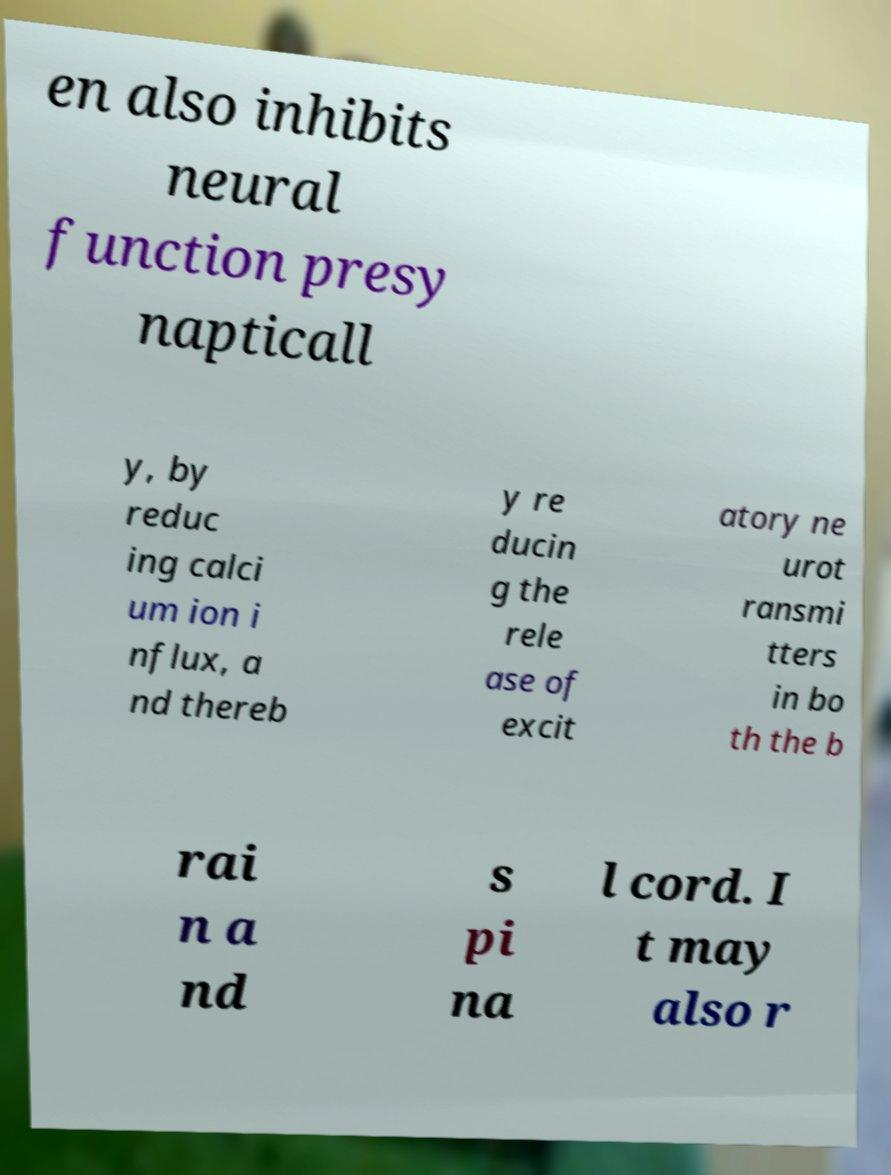Can you accurately transcribe the text from the provided image for me? en also inhibits neural function presy napticall y, by reduc ing calci um ion i nflux, a nd thereb y re ducin g the rele ase of excit atory ne urot ransmi tters in bo th the b rai n a nd s pi na l cord. I t may also r 